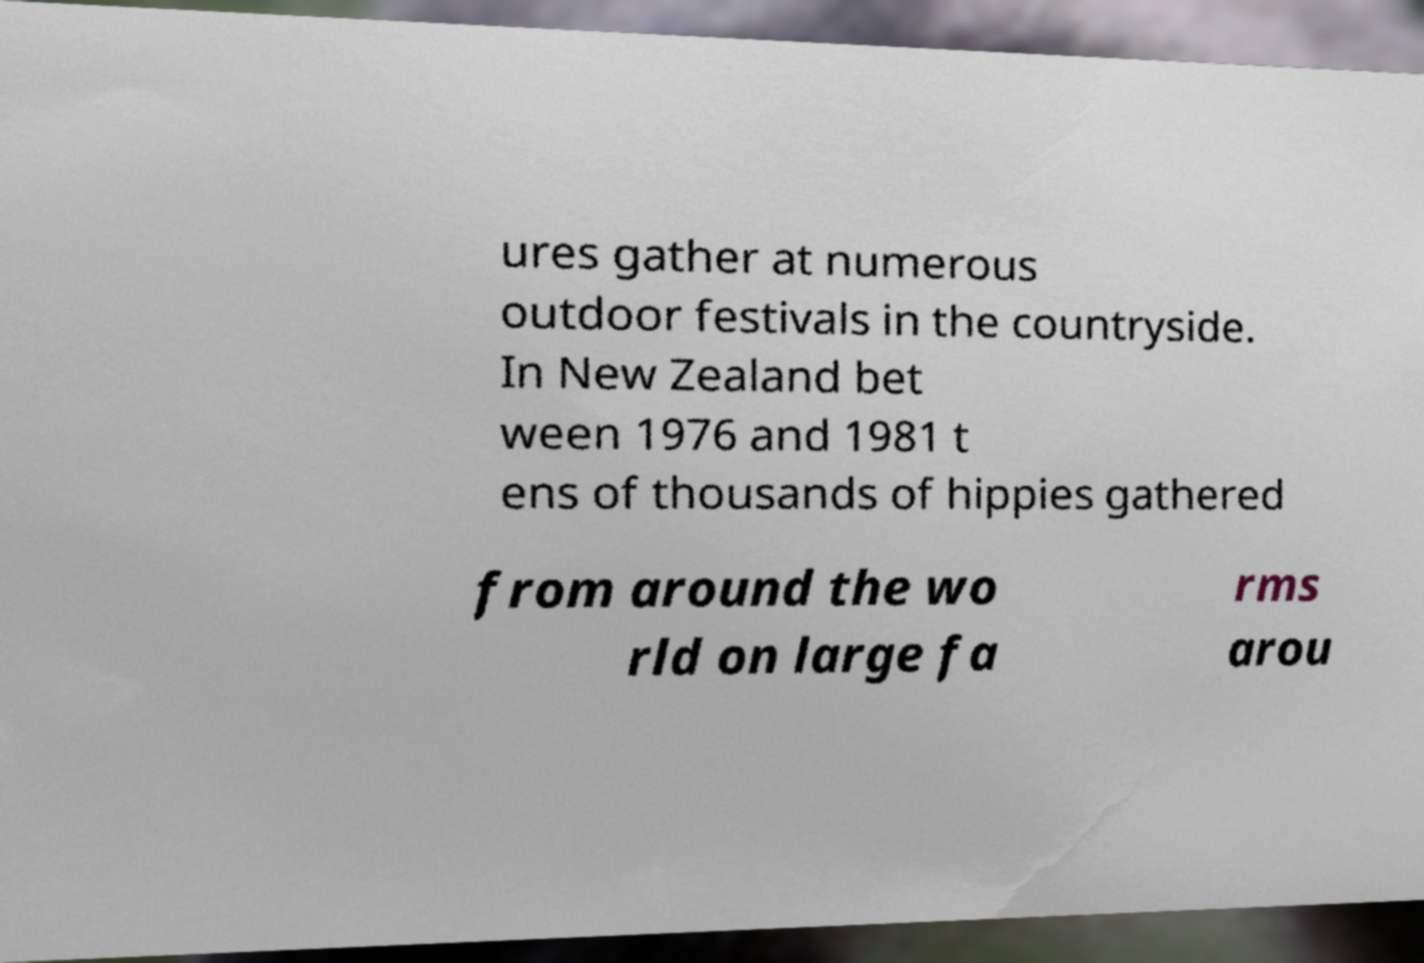Please read and relay the text visible in this image. What does it say? ures gather at numerous outdoor festivals in the countryside. In New Zealand bet ween 1976 and 1981 t ens of thousands of hippies gathered from around the wo rld on large fa rms arou 